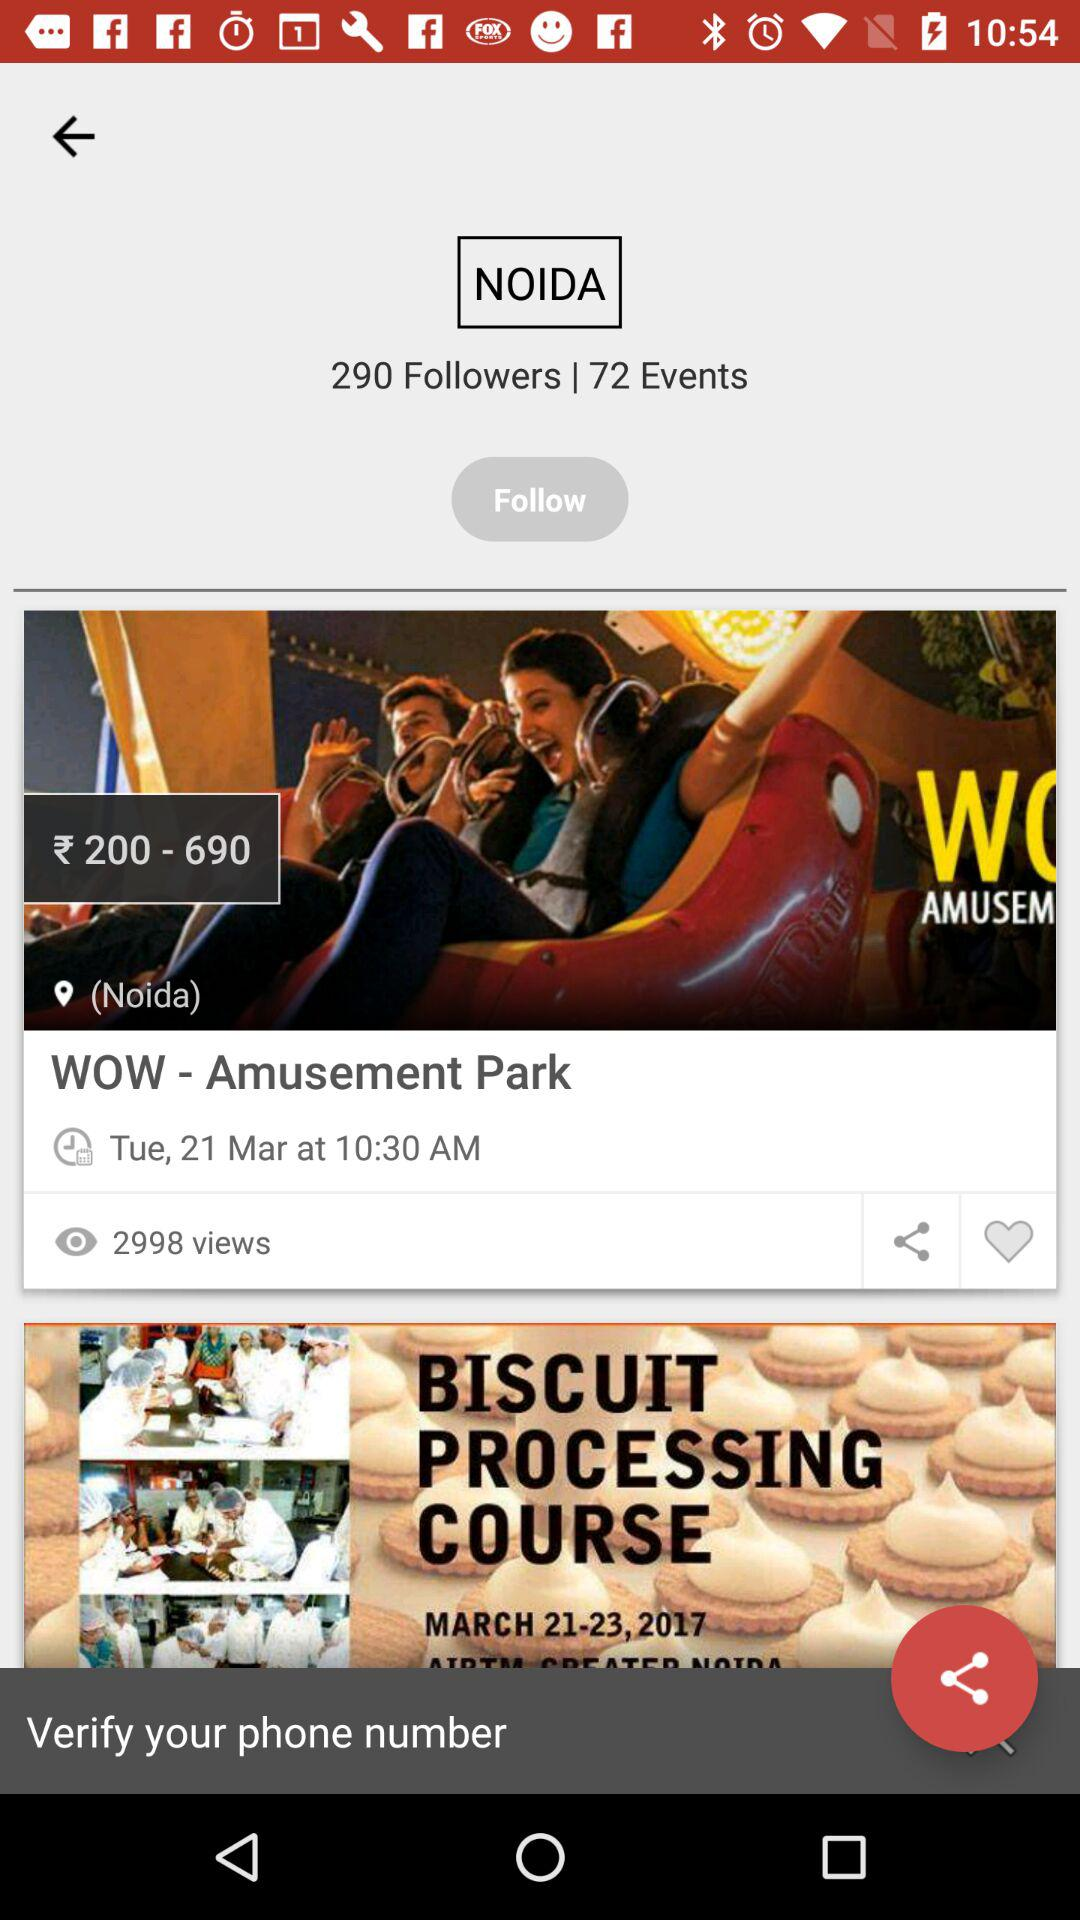What is the name of the course? The name of the course is "BISCUIT PROCESSING COURSE". 